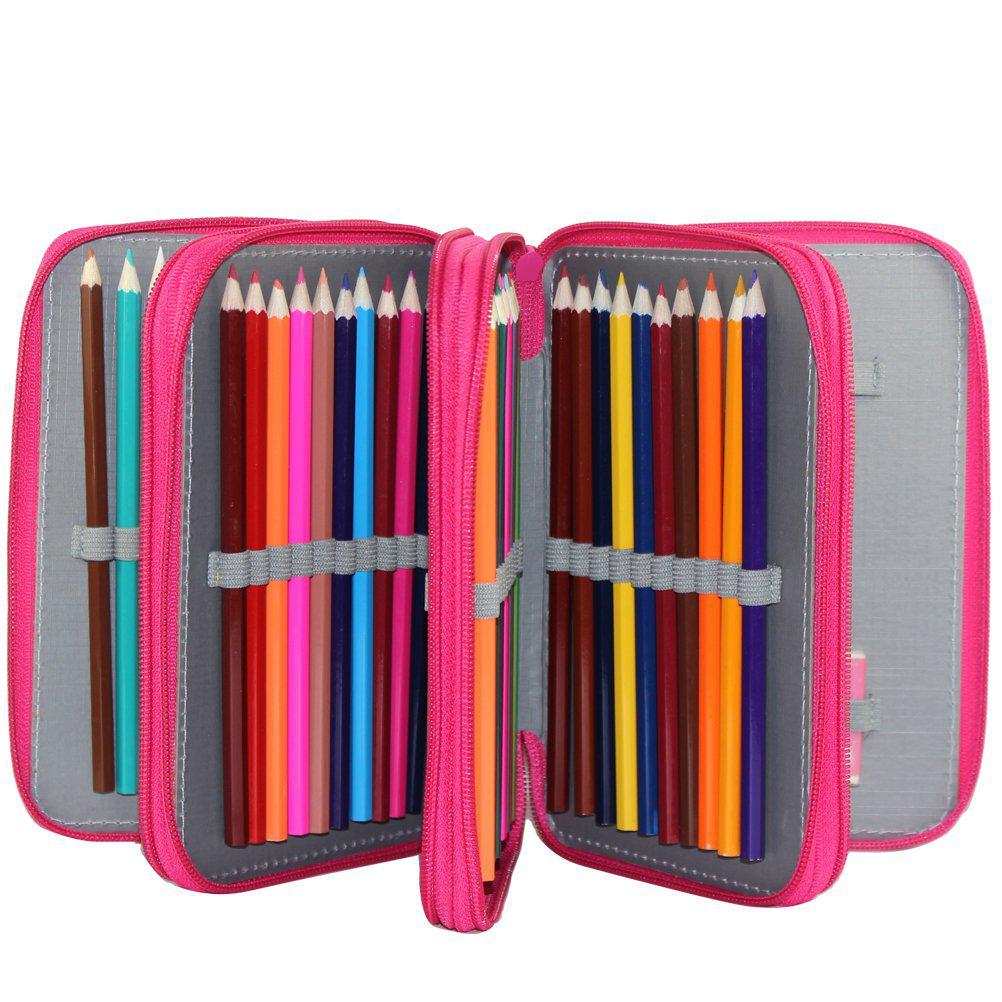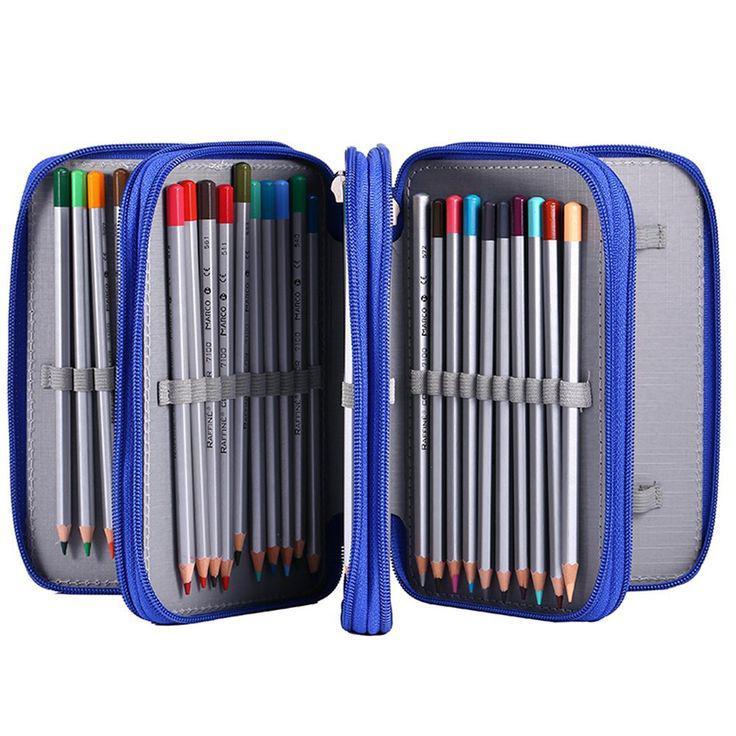The first image is the image on the left, the second image is the image on the right. Evaluate the accuracy of this statement regarding the images: "One of the images shows a pencil case with a ruler inside.". Is it true? Answer yes or no. No. 